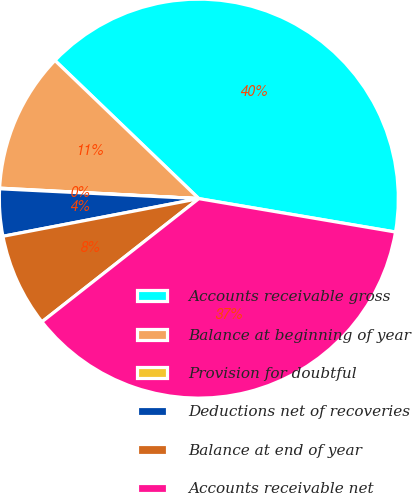Convert chart. <chart><loc_0><loc_0><loc_500><loc_500><pie_chart><fcel>Accounts receivable gross<fcel>Balance at beginning of year<fcel>Provision for doubtful<fcel>Deductions net of recoveries<fcel>Balance at end of year<fcel>Accounts receivable net<nl><fcel>40.5%<fcel>11.34%<fcel>0.05%<fcel>3.81%<fcel>7.57%<fcel>36.73%<nl></chart> 